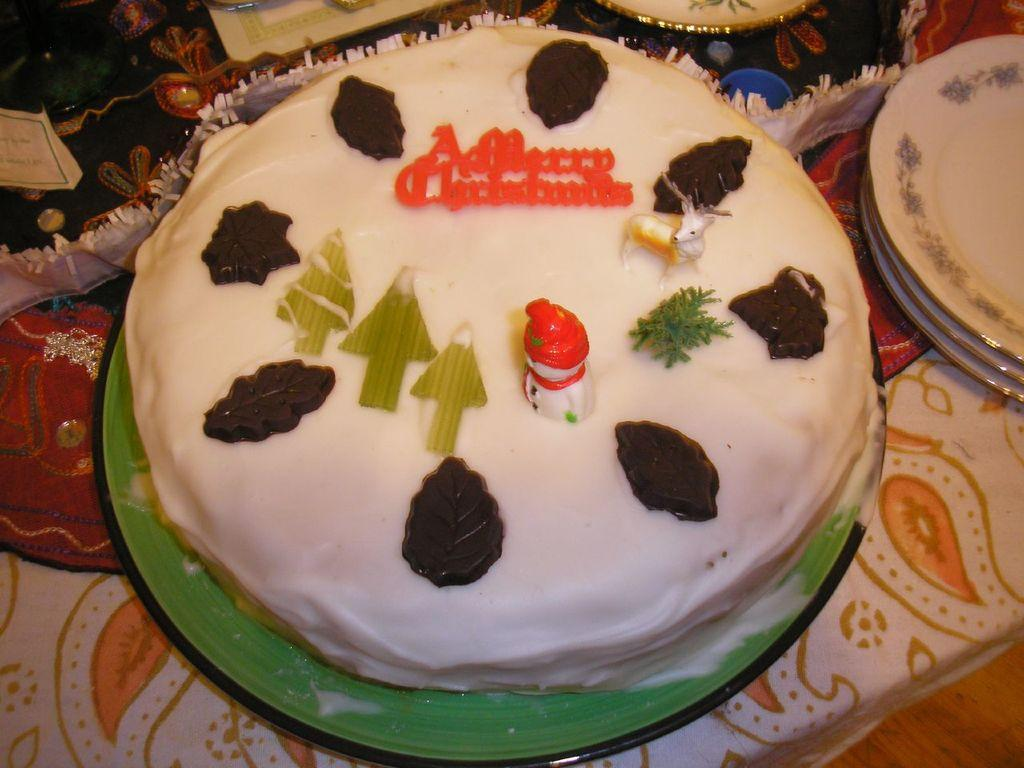What type of furniture is present in the image? There is a table in the image. What is placed on the table? There are plates on the table. What is the main food item on the table? There is a cake on top of a plate. Are there any other objects on the table besides plates and the cake? Yes, there are other objects on the table. Can you tell me where the bomb is located in the image? There is no bomb present in the image. What type of ornament is placed on the table in the image? The provided facts do not mention any ornaments on the table, so we cannot determine if there is one or not. 